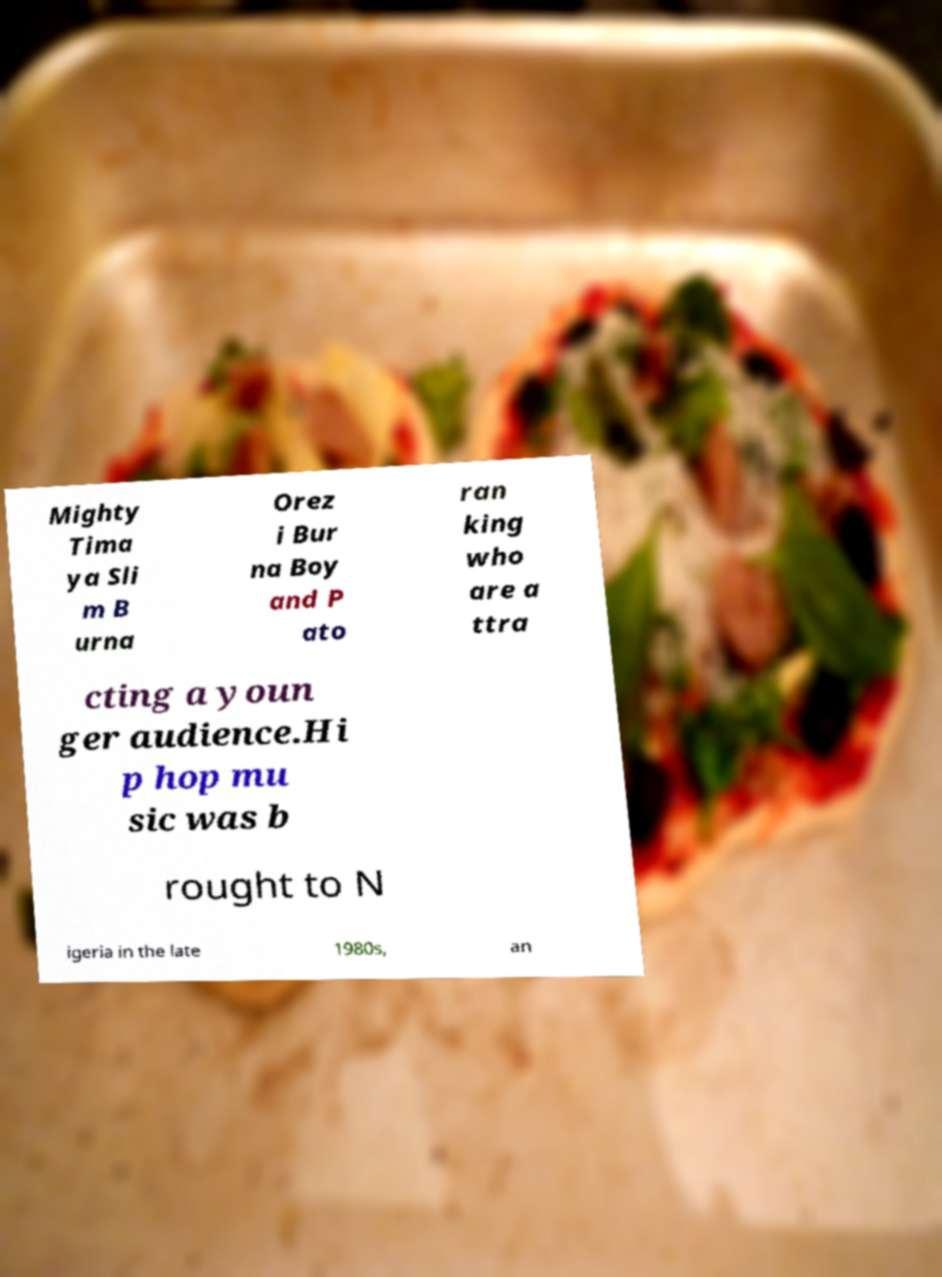There's text embedded in this image that I need extracted. Can you transcribe it verbatim? Mighty Tima ya Sli m B urna Orez i Bur na Boy and P ato ran king who are a ttra cting a youn ger audience.Hi p hop mu sic was b rought to N igeria in the late 1980s, an 